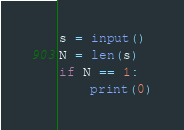Convert code to text. <code><loc_0><loc_0><loc_500><loc_500><_Python_>s = input()
N = len(s)
if N == 1:
	print(0)
</code> 